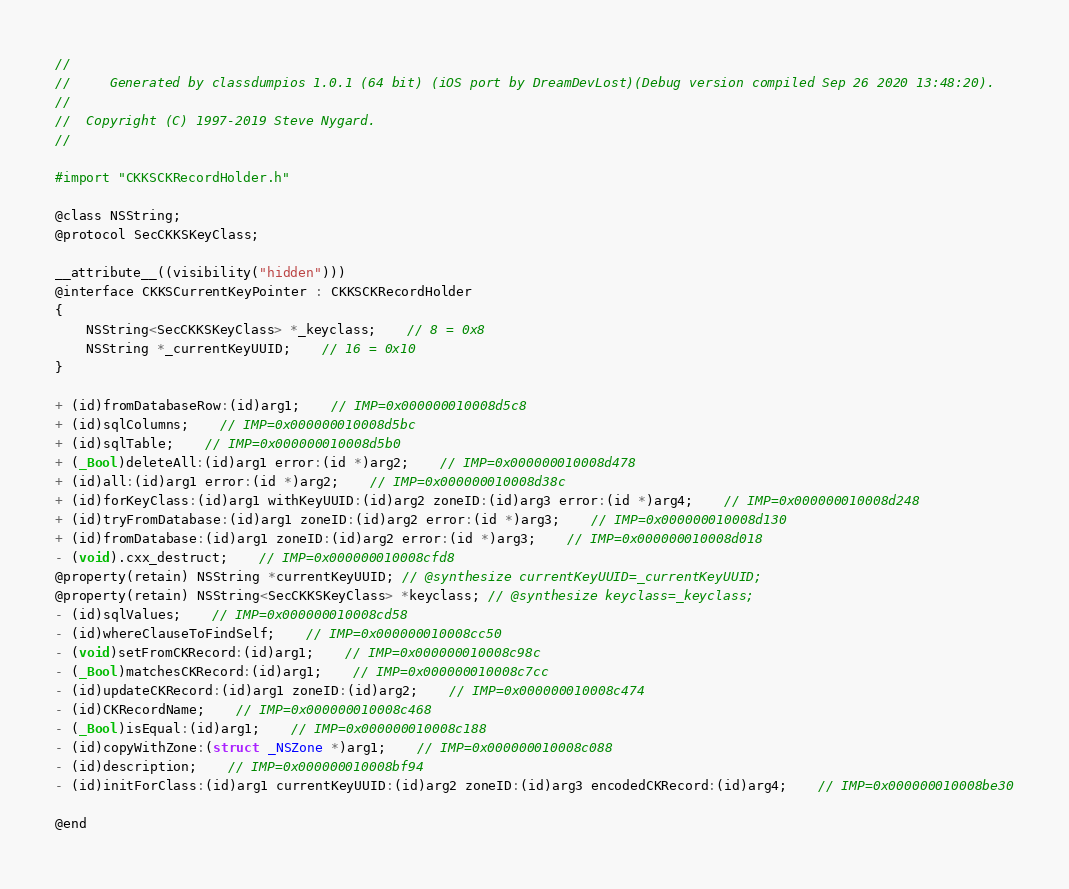Convert code to text. <code><loc_0><loc_0><loc_500><loc_500><_C_>//
//     Generated by classdumpios 1.0.1 (64 bit) (iOS port by DreamDevLost)(Debug version compiled Sep 26 2020 13:48:20).
//
//  Copyright (C) 1997-2019 Steve Nygard.
//

#import "CKKSCKRecordHolder.h"

@class NSString;
@protocol SecCKKSKeyClass;

__attribute__((visibility("hidden")))
@interface CKKSCurrentKeyPointer : CKKSCKRecordHolder
{
    NSString<SecCKKSKeyClass> *_keyclass;	// 8 = 0x8
    NSString *_currentKeyUUID;	// 16 = 0x10
}

+ (id)fromDatabaseRow:(id)arg1;	// IMP=0x000000010008d5c8
+ (id)sqlColumns;	// IMP=0x000000010008d5bc
+ (id)sqlTable;	// IMP=0x000000010008d5b0
+ (_Bool)deleteAll:(id)arg1 error:(id *)arg2;	// IMP=0x000000010008d478
+ (id)all:(id)arg1 error:(id *)arg2;	// IMP=0x000000010008d38c
+ (id)forKeyClass:(id)arg1 withKeyUUID:(id)arg2 zoneID:(id)arg3 error:(id *)arg4;	// IMP=0x000000010008d248
+ (id)tryFromDatabase:(id)arg1 zoneID:(id)arg2 error:(id *)arg3;	// IMP=0x000000010008d130
+ (id)fromDatabase:(id)arg1 zoneID:(id)arg2 error:(id *)arg3;	// IMP=0x000000010008d018
- (void).cxx_destruct;	// IMP=0x000000010008cfd8
@property(retain) NSString *currentKeyUUID; // @synthesize currentKeyUUID=_currentKeyUUID;
@property(retain) NSString<SecCKKSKeyClass> *keyclass; // @synthesize keyclass=_keyclass;
- (id)sqlValues;	// IMP=0x000000010008cd58
- (id)whereClauseToFindSelf;	// IMP=0x000000010008cc50
- (void)setFromCKRecord:(id)arg1;	// IMP=0x000000010008c98c
- (_Bool)matchesCKRecord:(id)arg1;	// IMP=0x000000010008c7cc
- (id)updateCKRecord:(id)arg1 zoneID:(id)arg2;	// IMP=0x000000010008c474
- (id)CKRecordName;	// IMP=0x000000010008c468
- (_Bool)isEqual:(id)arg1;	// IMP=0x000000010008c188
- (id)copyWithZone:(struct _NSZone *)arg1;	// IMP=0x000000010008c088
- (id)description;	// IMP=0x000000010008bf94
- (id)initForClass:(id)arg1 currentKeyUUID:(id)arg2 zoneID:(id)arg3 encodedCKRecord:(id)arg4;	// IMP=0x000000010008be30

@end

</code> 